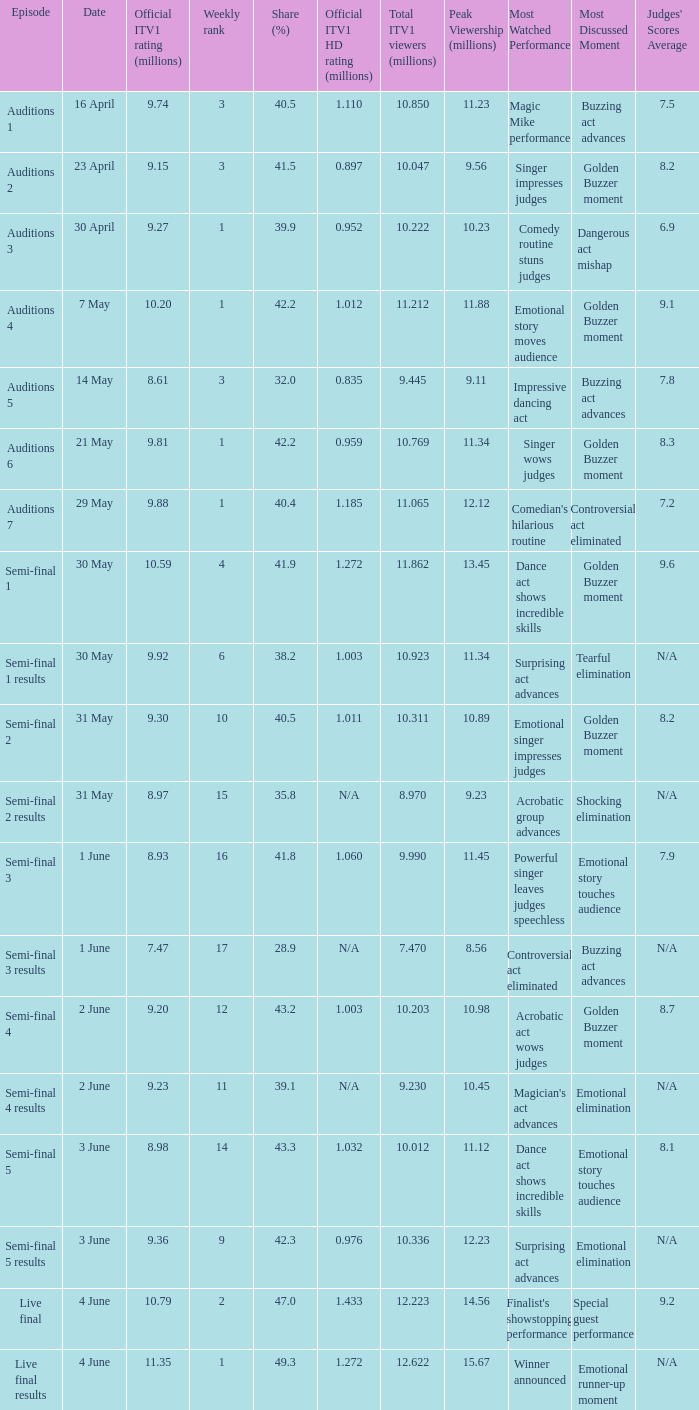Which episode had an official ITV1 HD rating of 1.185 million?  Auditions 7. 